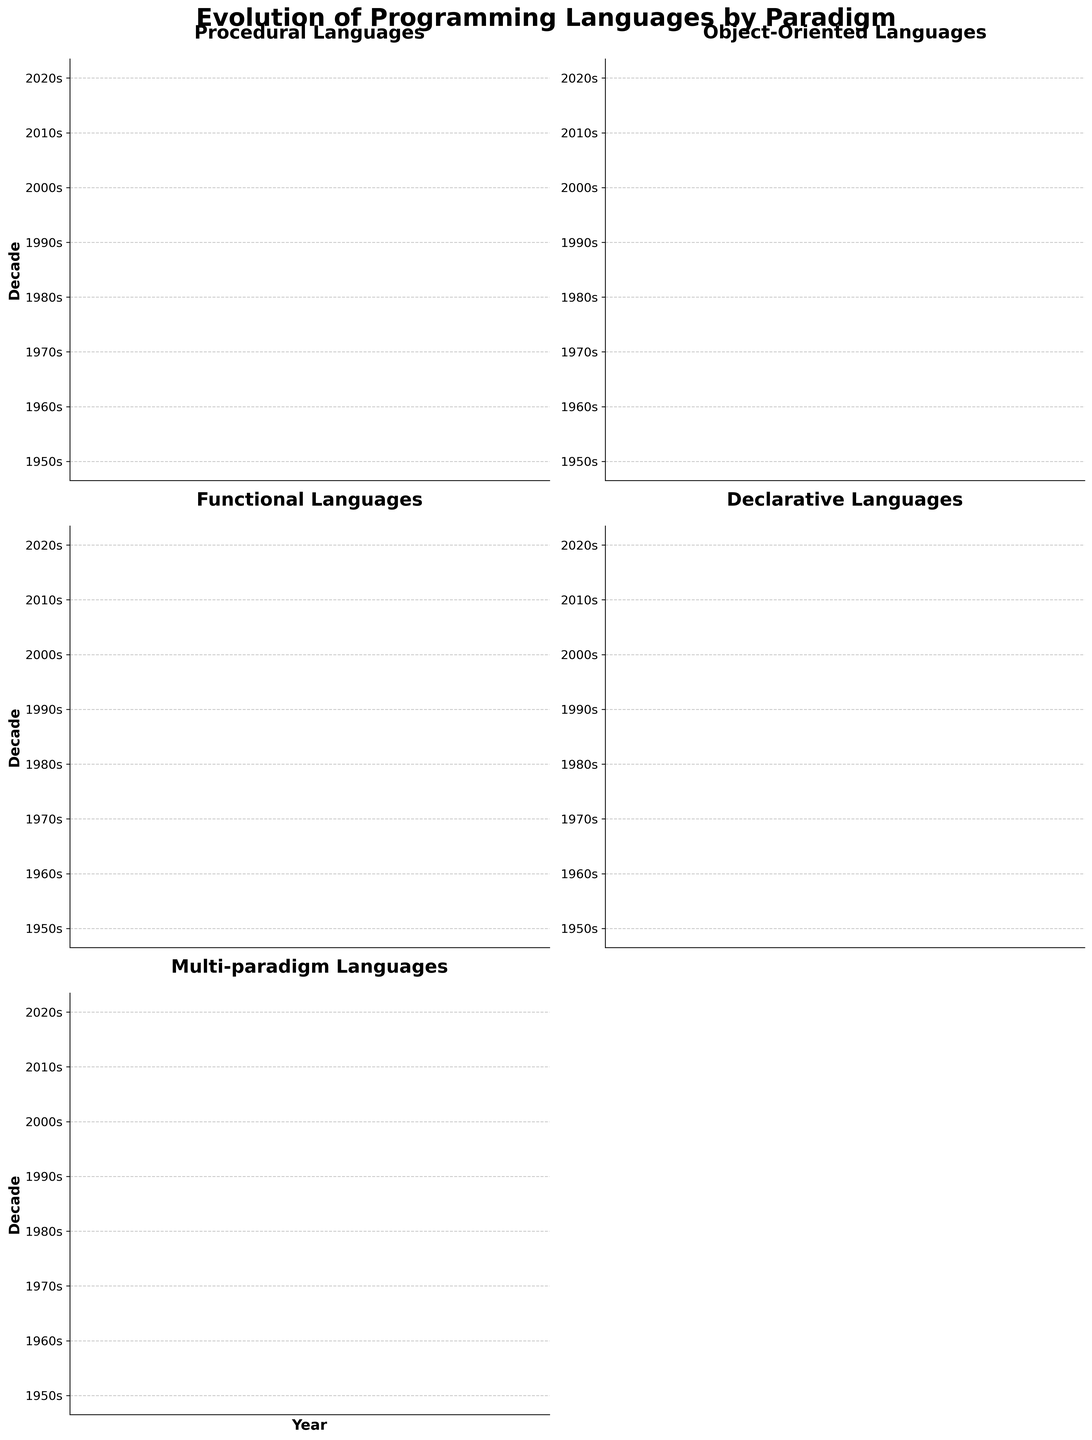What are the titles of the subplots? Each subplot represents a different programming paradigm: Procedural, Object-Oriented, Functional, Declarative, and Multi-paradigm. These titles can be seen at the top of each individual subplot.
Answer: Procedural, Object-Oriented, Functional, Declarative, Multi-paradigm Which decade has the most diverse language evolution across paradigms? By observing the subplots, the 1990s appear to have the most languages across different paradigms, including COBOL 2002, Java, Haskell, HTML, and Python.
Answer: 1990s In which decade does Object-Oriented programming have two notable languages? The 1980s show both C++ and Ada under Object-Oriented programming. This observation can be made by looking specifically at the Object-Oriented subplot.
Answer: 1980s How many languages are represented in the 2000s across all paradigms? We count the number of languages listed in the 2000s across all subplots: Go (Procedural), C# (Object-Oriented), F# (Functional), XAML (Declarative), and Scala (Multi-paradigm), leading to a total of five languages.
Answer: 5 Which paradigm appears to have introduced a language the earliest? Procedural programming appears to have introduced FORTRAN in the 1950s, which is visible in the Procedural subplot.
Answer: Procedural Do the 2010s contribute any languages to the Functional paradigm? By inspecting the Functional Languages subplot, we can see that Clojure was introduced in the 2010s.
Answer: Yes Which programming paradigm is the most recent to introduce a new language in the 2020s? By referring to the subplots, we notice that the most recent languages in the 2020s are: Zig (Procedural), Dart (Object-Oriented), Elixir (Functional), Julia (Declarative), and TypeScript (Multi-paradigm).
Answer: All paradigms How many paradigms had new languages introduced in the 1980s? By checking the entries for the 1980s across all subplots, we see new languages in Procedural (Ada), Object-Oriented (C++), Functional (Miranda), Declarative (SQL), and Multi-paradigm (Perl), adding up to five paradigms.
Answer: 5 Which two decades have an equal number of new languages introduced in the Declarative paradigm? Observing the Declarative Languages subplot, the 1960s (SNOBOL) and the 2000s (XAML) both introduced one language each.
Answer: 1960s and 2000s 